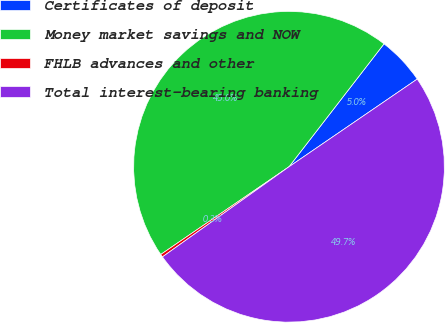<chart> <loc_0><loc_0><loc_500><loc_500><pie_chart><fcel>Certificates of deposit<fcel>Money market savings and NOW<fcel>FHLB advances and other<fcel>Total interest-bearing banking<nl><fcel>4.98%<fcel>45.02%<fcel>0.3%<fcel>49.7%<nl></chart> 